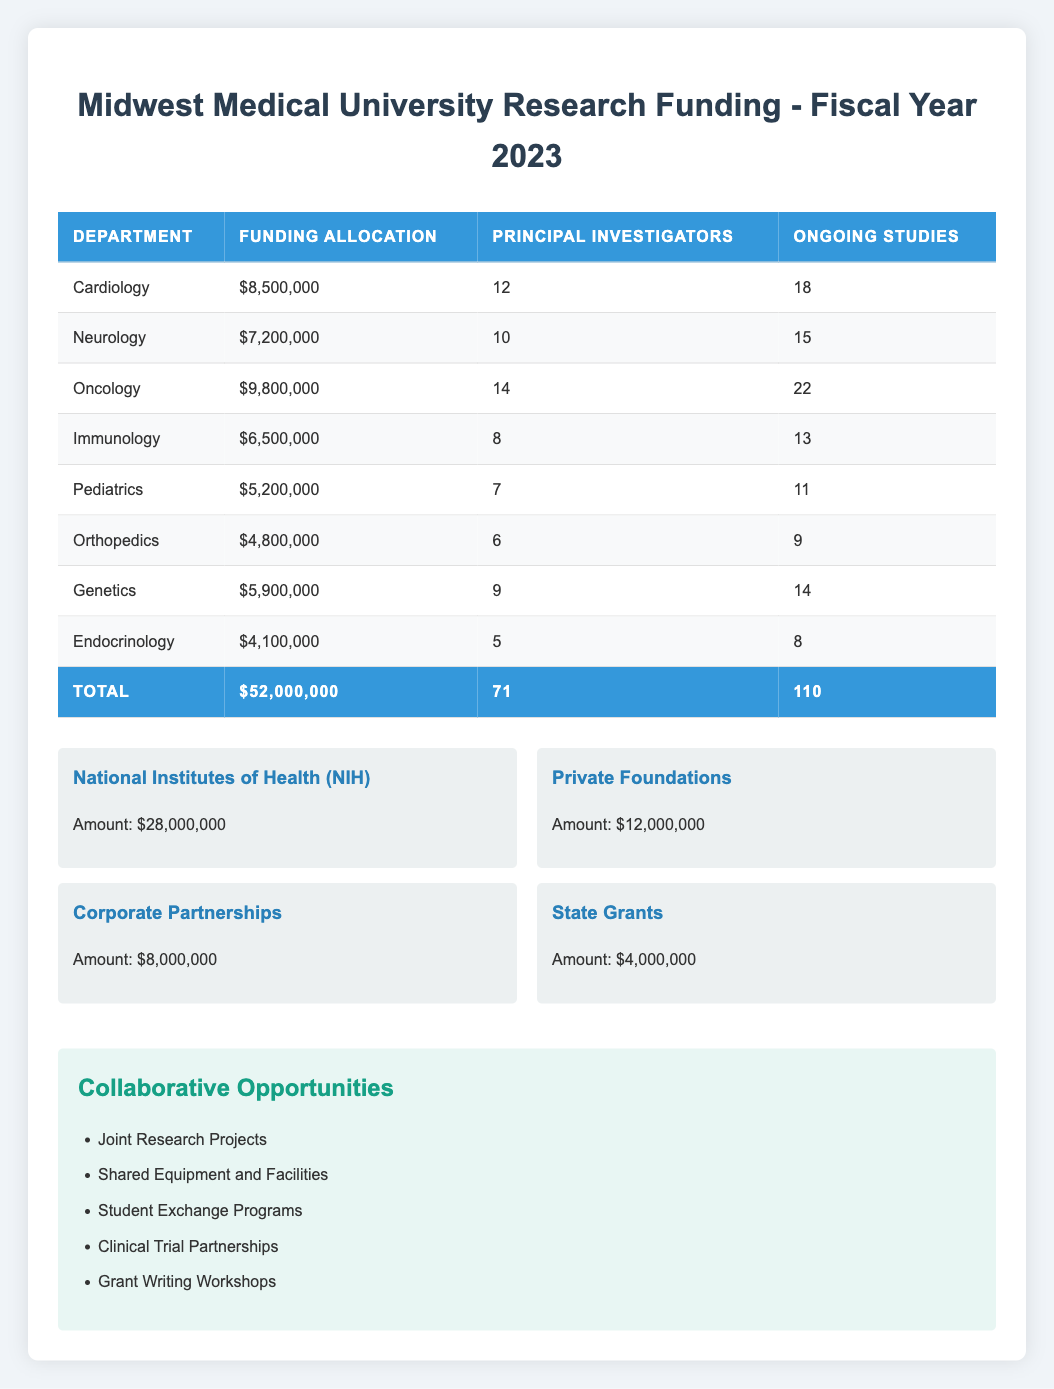What is the total research funding allocated for the Oncology department? The Oncology department has a funding allocation of 9,800,000 according to the table.
Answer: 9,800,000 How many principal investigators are dedicated to the Cardiology department? The number of principal investigators assigned to the Cardiology department is 12 as per the data shown in the table.
Answer: 12 Which department has the lowest funding allocation? By comparing the funding allocations for all departments, the Endocrinology department with 4,100,000 has the lowest funding allocation.
Answer: Endocrinology What is the total number of principal investigators across all departments? To find the total number of principal investigators, we sum the values: 12 + 10 + 14 + 8 + 7 + 6 + 9 + 5 = 71.
Answer: 71 Is the funding allocation for Neurology more than 7 million? The funding allocation for Neurology is 7,200,000, which is greater than 7 million, thus the statement is true.
Answer: Yes What is the average funding allocation for all departments? To calculate the average funding, we total all the funding allocations (8,500,000 + 7,200,000 + 9,800,000 + 6,500,000 + 5,200,000 + 4,800,000 + 5,900,000 + 4,100,000 = 52,000,000), and divide by the number of departments (8). The average funding allocation is 52,000,000 / 8 = 6,500,000.
Answer: 6,500,000 Which funding source contributes the most to the total research funding? By comparing the amounts from each funding source, the National Institutes of Health (NIH) contributes the highest amount of 28,000,000.
Answer: National Institutes of Health (NIH) Are there more than 100 ongoing studies across all departments? The total number of ongoing studies is calculated by summing each department's ongoing studies: 18 + 15 + 22 + 13 + 11 + 9 + 14 + 8 = 110. Since 110 is not greater than 100, the statement is false.
Answer: No What percentage of the total research funding is dedicated to the Genetics department? To find the percentage, divide the funding allocation for Genetics (5,900,000) by the total research funding (52,000,000), then multiply by 100. The calculation is (5,900,000 / 52,000,000) * 100 ≈ 11.35%.
Answer: Approximately 11.35% 